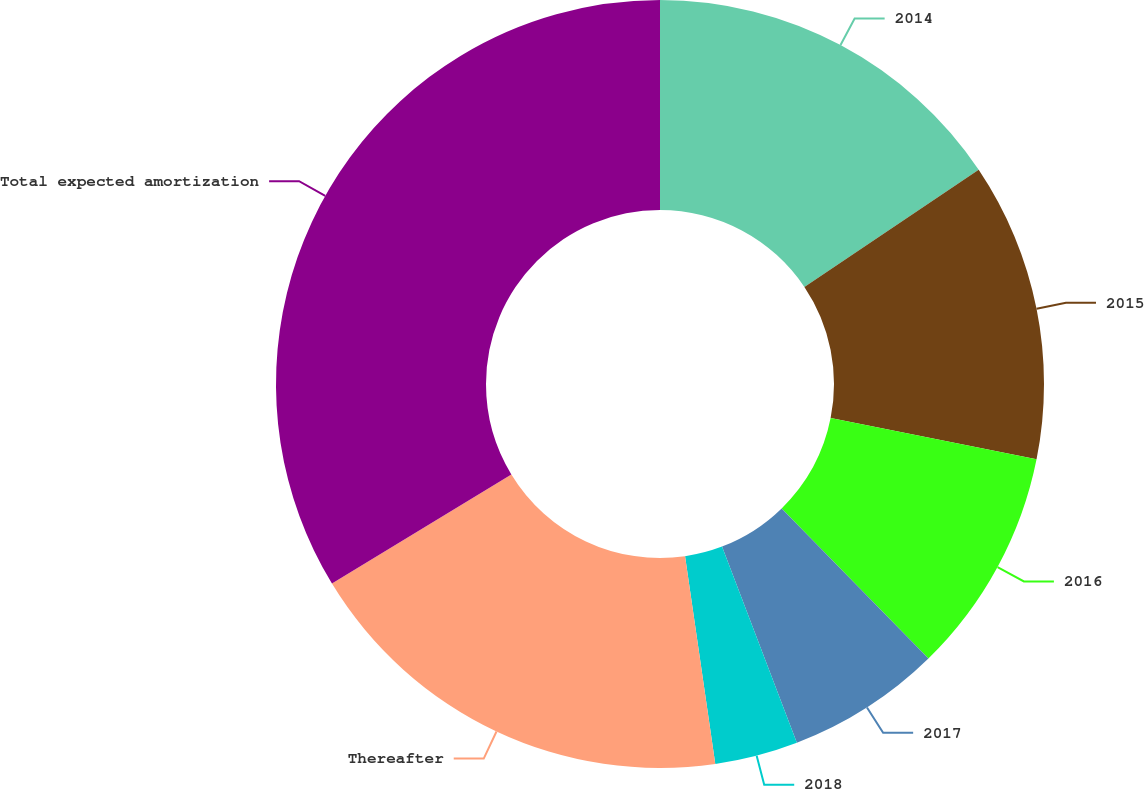Convert chart. <chart><loc_0><loc_0><loc_500><loc_500><pie_chart><fcel>2014<fcel>2015<fcel>2016<fcel>2017<fcel>2018<fcel>Thereafter<fcel>Total expected amortization<nl><fcel>15.58%<fcel>12.56%<fcel>9.54%<fcel>6.52%<fcel>3.5%<fcel>18.6%<fcel>33.7%<nl></chart> 